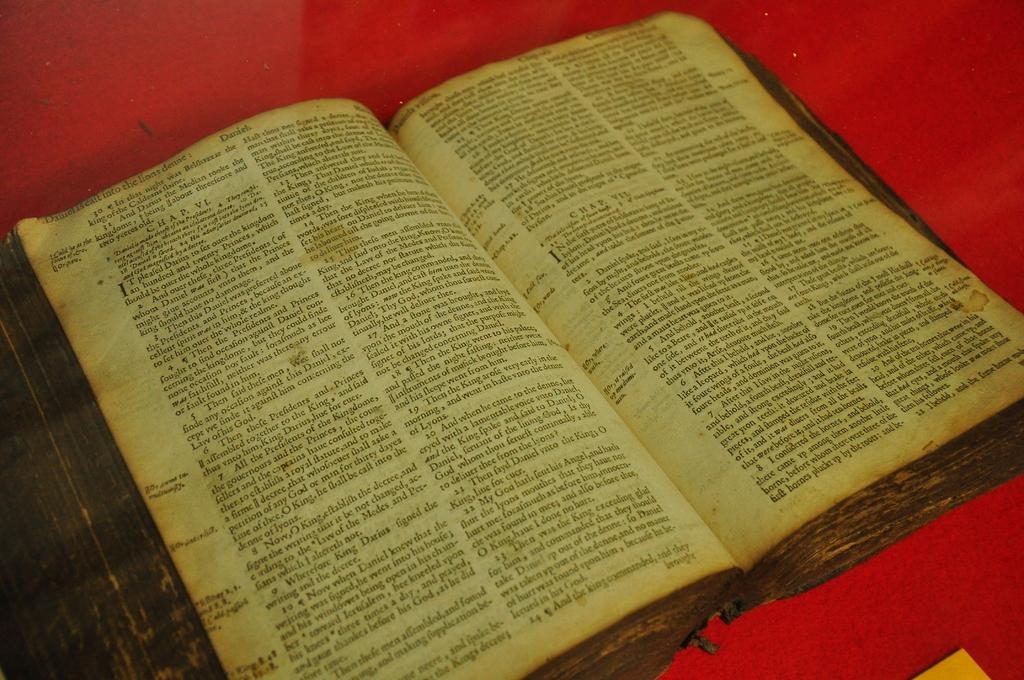<image>
Relay a brief, clear account of the picture shown. A very old book with paper turning yellow about a character named Daniel. 